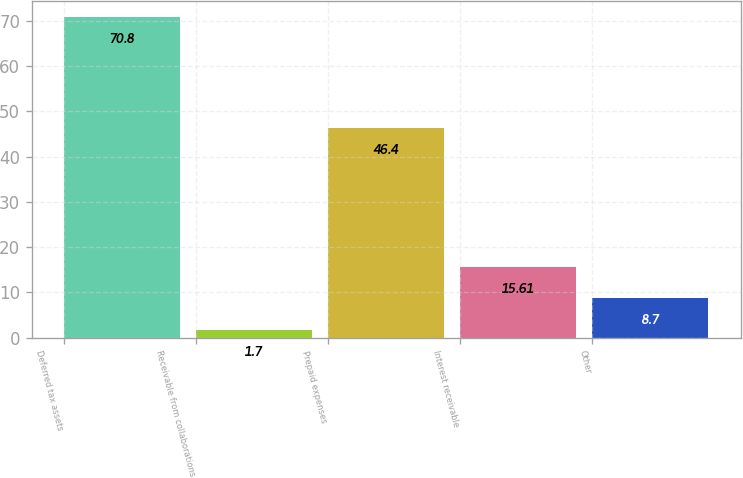Convert chart to OTSL. <chart><loc_0><loc_0><loc_500><loc_500><bar_chart><fcel>Deferred tax assets<fcel>Receivable from collaborations<fcel>Prepaid expenses<fcel>Interest receivable<fcel>Other<nl><fcel>70.8<fcel>1.7<fcel>46.4<fcel>15.61<fcel>8.7<nl></chart> 